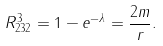<formula> <loc_0><loc_0><loc_500><loc_500>R ^ { 3 } _ { 2 3 2 } = 1 - e ^ { - \lambda } = \frac { 2 m } { r } .</formula> 